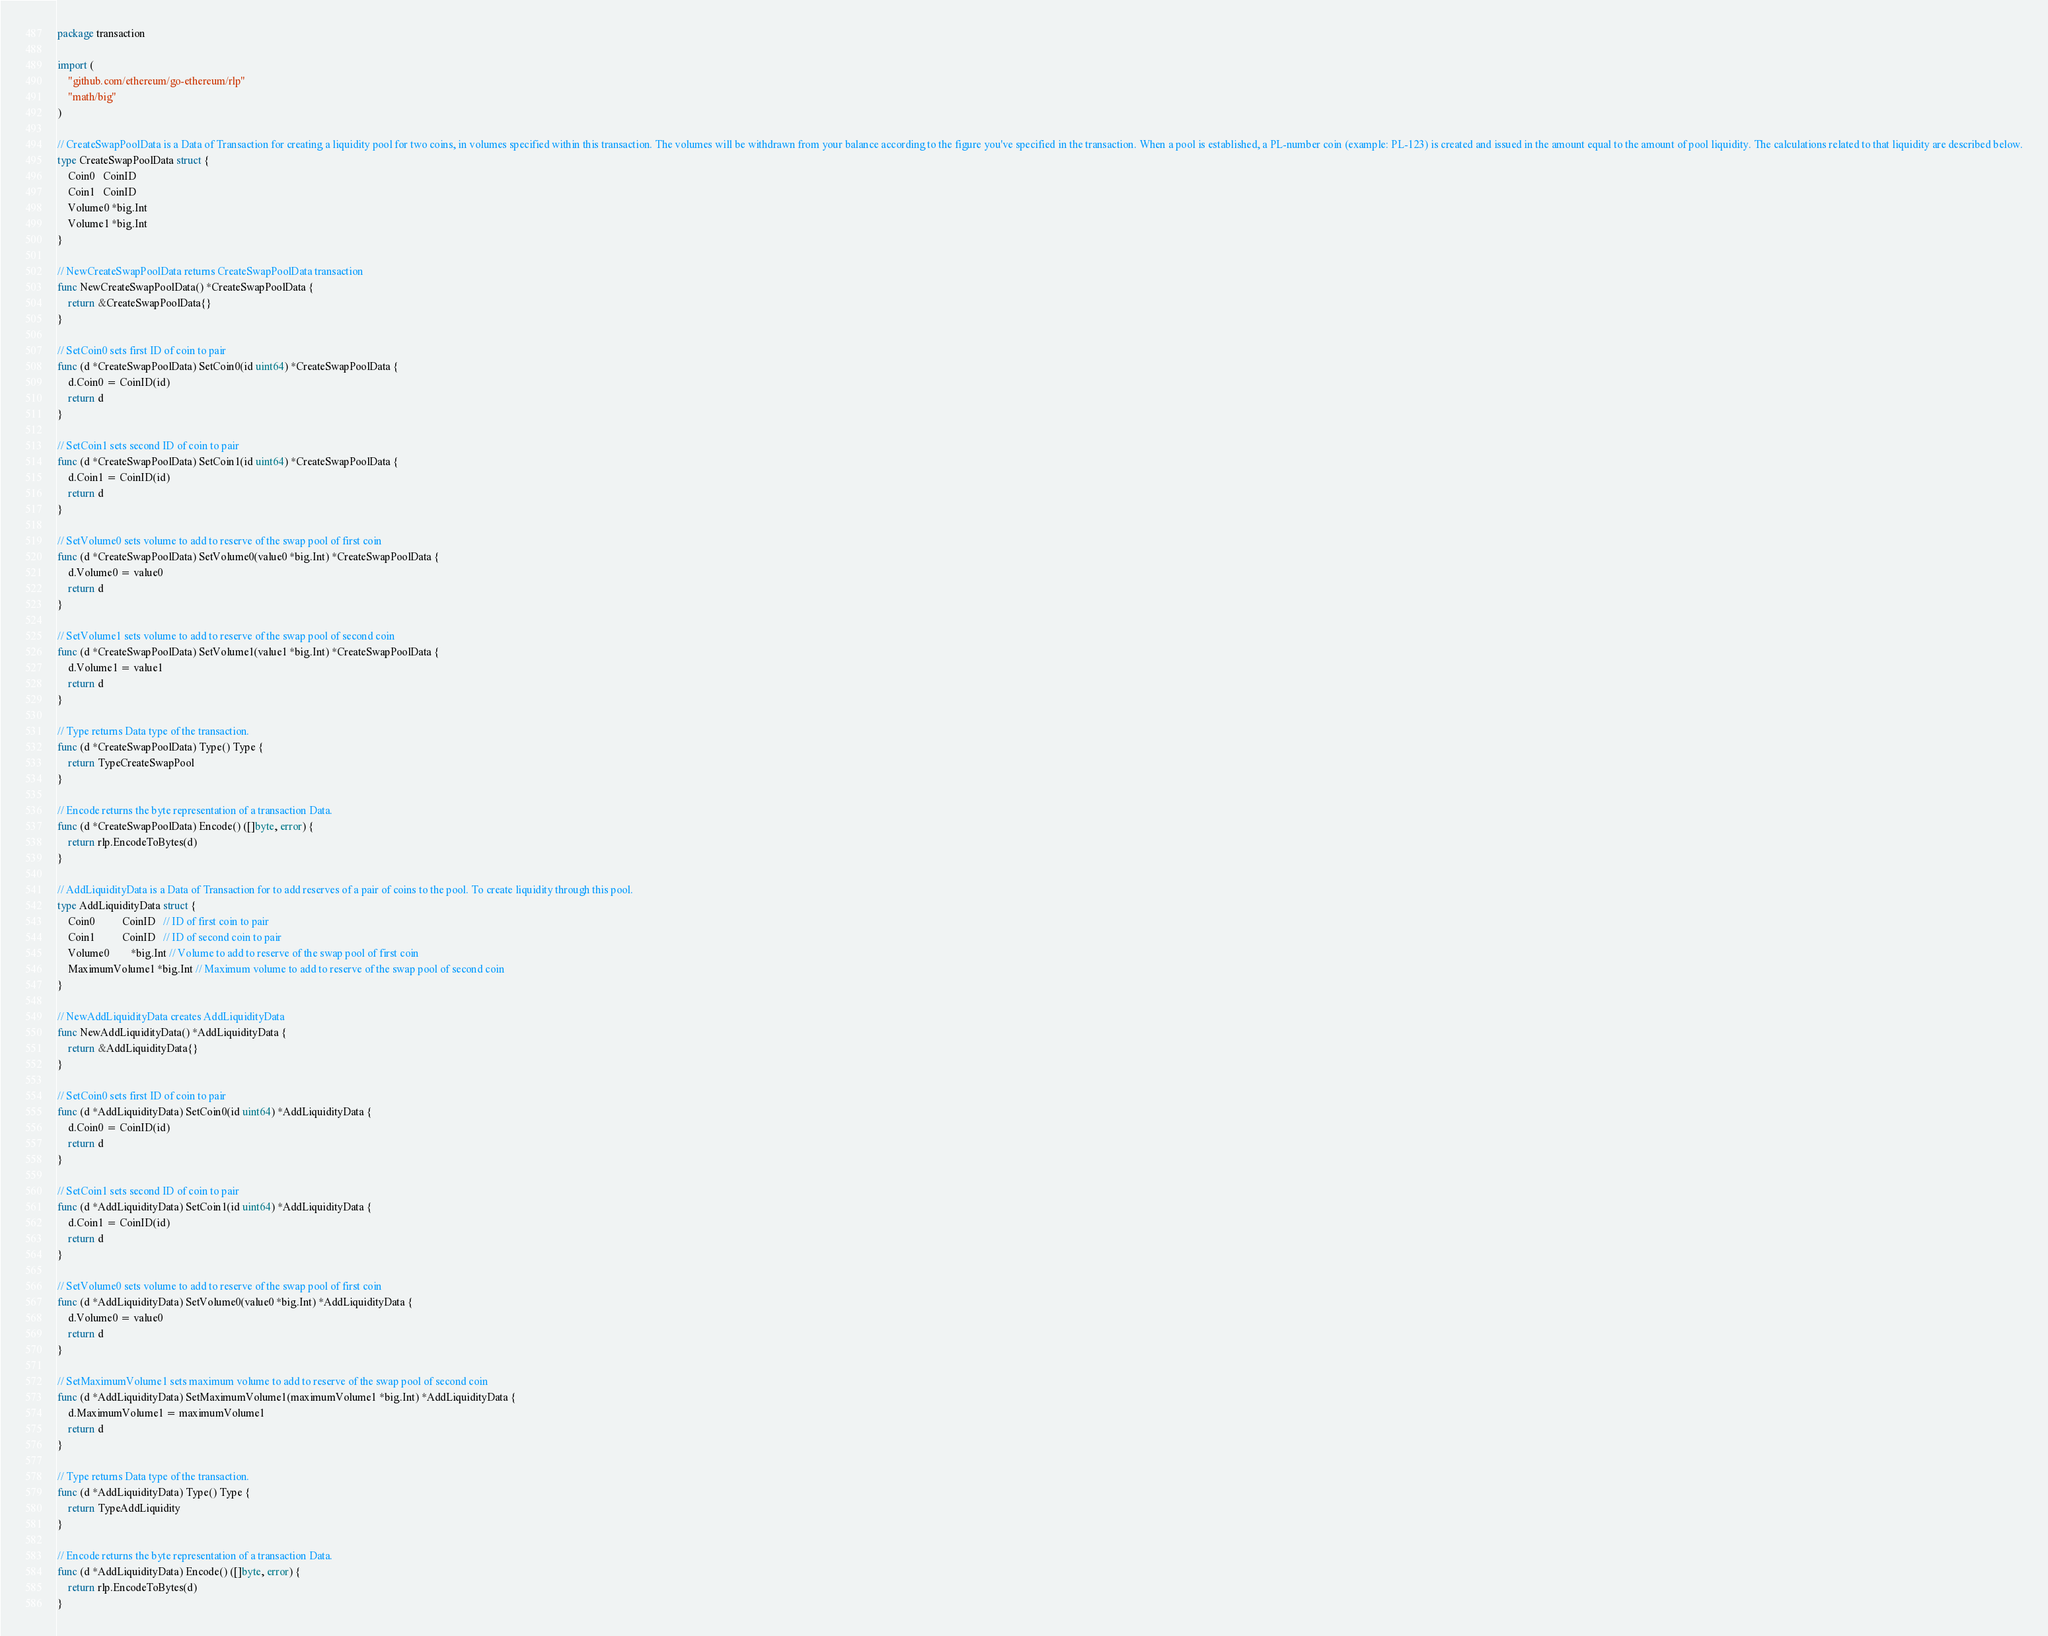Convert code to text. <code><loc_0><loc_0><loc_500><loc_500><_Go_>package transaction

import (
	"github.com/ethereum/go-ethereum/rlp"
	"math/big"
)

// CreateSwapPoolData is a Data of Transaction for creating a liquidity pool for two coins, in volumes specified within this transaction. The volumes will be withdrawn from your balance according to the figure you've specified in the transaction. When a pool is established, a PL-number coin (example: PL-123) is created and issued in the amount equal to the amount of pool liquidity. The calculations related to that liquidity are described below.
type CreateSwapPoolData struct {
	Coin0   CoinID
	Coin1   CoinID
	Volume0 *big.Int
	Volume1 *big.Int
}

// NewCreateSwapPoolData returns CreateSwapPoolData transaction
func NewCreateSwapPoolData() *CreateSwapPoolData {
	return &CreateSwapPoolData{}
}

// SetCoin0 sets first ID of coin to pair
func (d *CreateSwapPoolData) SetCoin0(id uint64) *CreateSwapPoolData {
	d.Coin0 = CoinID(id)
	return d
}

// SetCoin1 sets second ID of coin to pair
func (d *CreateSwapPoolData) SetCoin1(id uint64) *CreateSwapPoolData {
	d.Coin1 = CoinID(id)
	return d
}

// SetVolume0 sets volume to add to reserve of the swap pool of first coin
func (d *CreateSwapPoolData) SetVolume0(value0 *big.Int) *CreateSwapPoolData {
	d.Volume0 = value0
	return d
}

// SetVolume1 sets volume to add to reserve of the swap pool of second coin
func (d *CreateSwapPoolData) SetVolume1(value1 *big.Int) *CreateSwapPoolData {
	d.Volume1 = value1
	return d
}

// Type returns Data type of the transaction.
func (d *CreateSwapPoolData) Type() Type {
	return TypeCreateSwapPool
}

// Encode returns the byte representation of a transaction Data.
func (d *CreateSwapPoolData) Encode() ([]byte, error) {
	return rlp.EncodeToBytes(d)
}

// AddLiquidityData is a Data of Transaction for to add reserves of a pair of coins to the pool. To create liquidity through this pool.
type AddLiquidityData struct {
	Coin0          CoinID   // ID of first coin to pair
	Coin1          CoinID   // ID of second coin to pair
	Volume0        *big.Int // Volume to add to reserve of the swap pool of first coin
	MaximumVolume1 *big.Int // Maximum volume to add to reserve of the swap pool of second coin
}

// NewAddLiquidityData creates AddLiquidityData
func NewAddLiquidityData() *AddLiquidityData {
	return &AddLiquidityData{}
}

// SetCoin0 sets first ID of coin to pair
func (d *AddLiquidityData) SetCoin0(id uint64) *AddLiquidityData {
	d.Coin0 = CoinID(id)
	return d
}

// SetCoin1 sets second ID of coin to pair
func (d *AddLiquidityData) SetCoin1(id uint64) *AddLiquidityData {
	d.Coin1 = CoinID(id)
	return d
}

// SetVolume0 sets volume to add to reserve of the swap pool of first coin
func (d *AddLiquidityData) SetVolume0(value0 *big.Int) *AddLiquidityData {
	d.Volume0 = value0
	return d
}

// SetMaximumVolume1 sets maximum volume to add to reserve of the swap pool of second coin
func (d *AddLiquidityData) SetMaximumVolume1(maximumVolume1 *big.Int) *AddLiquidityData {
	d.MaximumVolume1 = maximumVolume1
	return d
}

// Type returns Data type of the transaction.
func (d *AddLiquidityData) Type() Type {
	return TypeAddLiquidity
}

// Encode returns the byte representation of a transaction Data.
func (d *AddLiquidityData) Encode() ([]byte, error) {
	return rlp.EncodeToBytes(d)
}
</code> 